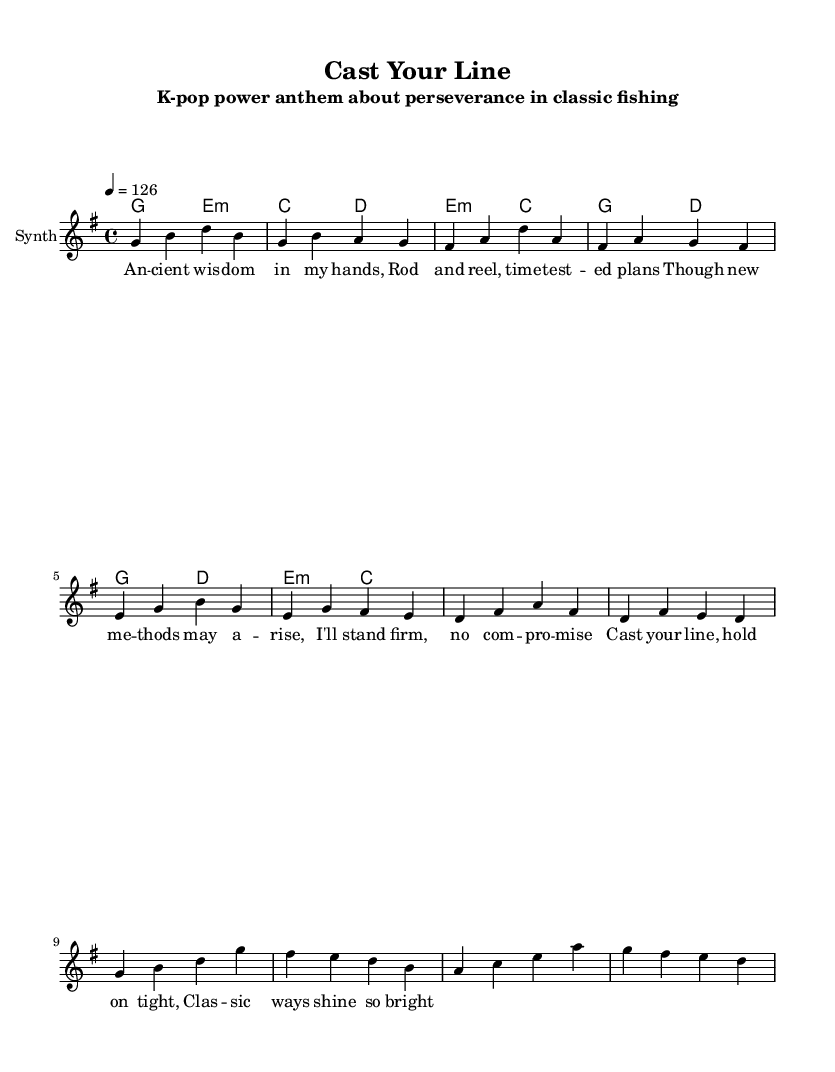What is the time signature of this music? The time signature is indicated at the beginning of the score as 4/4, which means there are four beats in each measure and the quarter note gets one beat.
Answer: 4/4 What is the tempo marking of this piece? The tempo marking is given as 4 = 126, indicating that there are 126 beats per minute. This is a moderate tempo often used in K-Pop songs.
Answer: 126 What is the key signature of this music? The key signature is identified as g major, which consists of one sharp (F#). This can be determined by the notes used in the melody and chords.
Answer: G major How many distinct sections are there in the song? The score contains three distinct sections: Verse, Pre-Chorus, and Chorus, each serving a unique purpose in the overall structure of the song.
Answer: Three Which chords are used in the pre-chorus? The pre-chorus uses the chords E minor and C major followed by G major and D major, as indicated in the chord mode section.
Answer: E minor, C major, G major, D major What message is conveyed in the chorus lyrics? The chorus emphasizes the theme of dedication to classic fishing methods by stating “Cast your line, hold on tight, Classic ways shine so bright,” highlighting the value of tradition.
Answer: Perseverance and dedication 